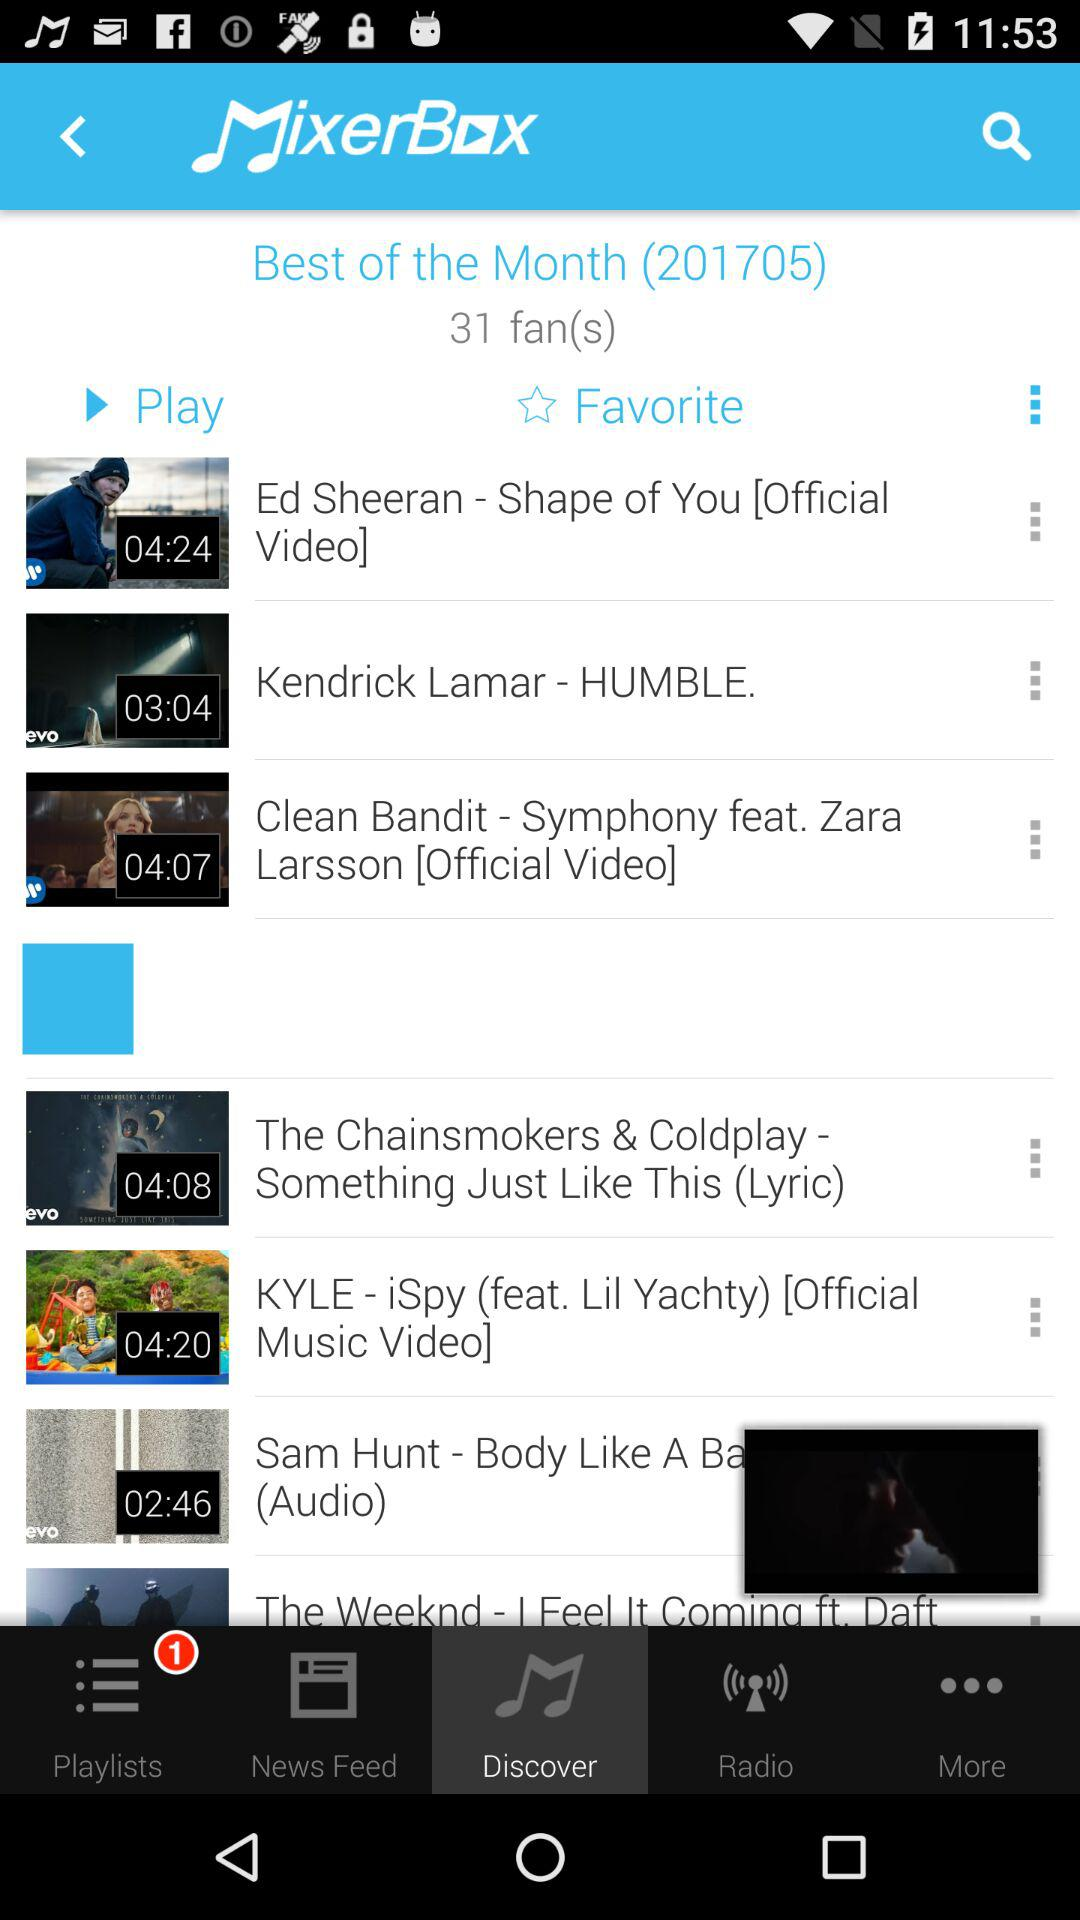What is the number of fans? The number of fans is 31. 